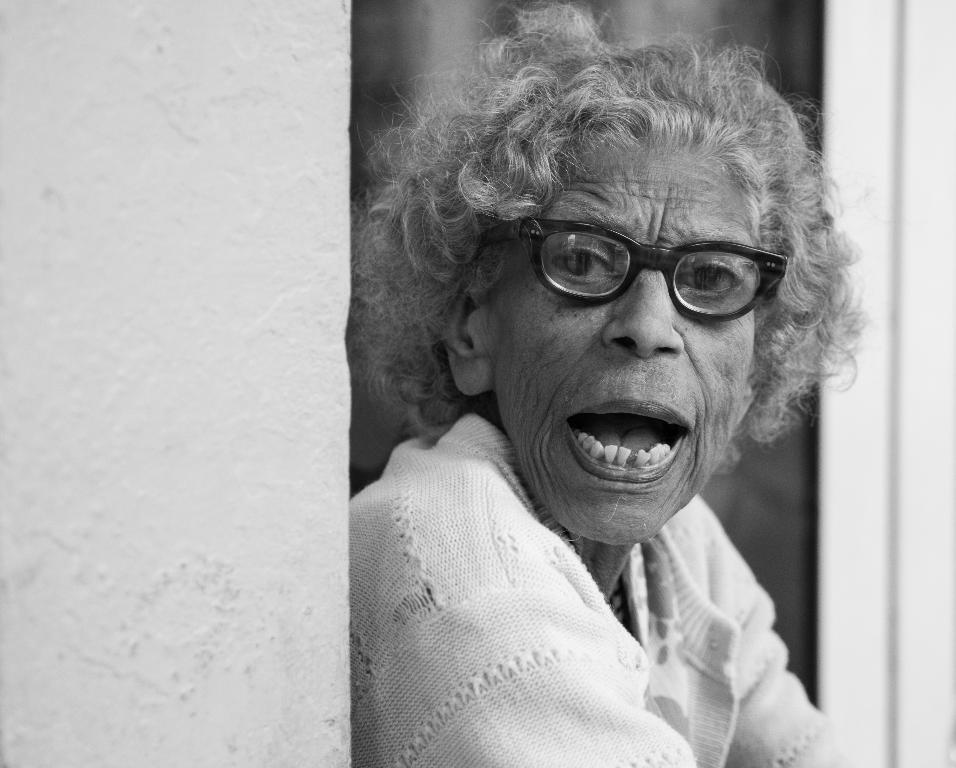Who is the main subject in the image? There is a person in the image. What is the person doing in the image? The person is speaking. What type of clothing is the person wearing in the image? The person is wearing a sweater. What accessory is the person wearing in the image? The person is wearing spectacles. How many sisters does the person in the image have? There is no information about the person's sisters in the image. What type of shoes is the person wearing in the image? There is no information about the person's shoes in the image. 